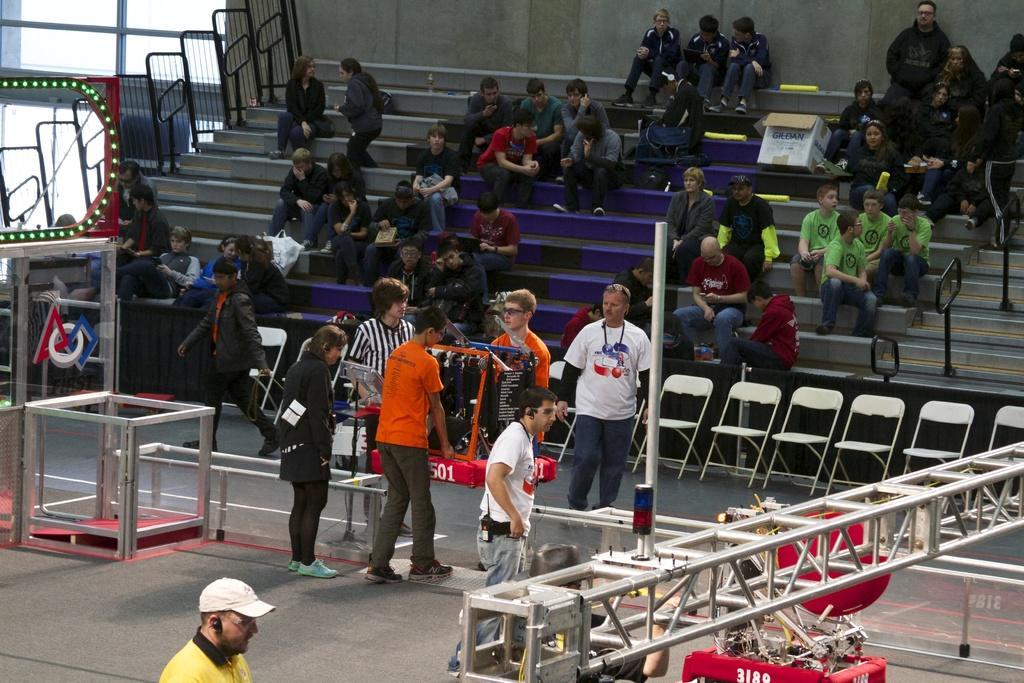In one or two sentences, can you explain what this image depicts? In the foreground I can see tables, metal rods, chairs and group of people are holding an object in hand. In the background I can see a crow is sitting on a stairs, fence and a wall. This image is taken during a day. 